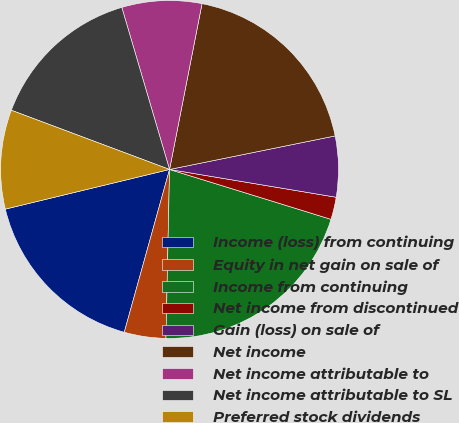<chart> <loc_0><loc_0><loc_500><loc_500><pie_chart><fcel>Income (loss) from continuing<fcel>Equity in net gain on sale of<fcel>Income from continuing<fcel>Net income from discontinued<fcel>Gain (loss) on sale of<fcel>Net income<fcel>Net income attributable to<fcel>Net income attributable to SL<fcel>Preferred stock dividends<nl><fcel>16.91%<fcel>3.98%<fcel>20.57%<fcel>2.14%<fcel>5.81%<fcel>18.74%<fcel>7.64%<fcel>14.74%<fcel>9.47%<nl></chart> 